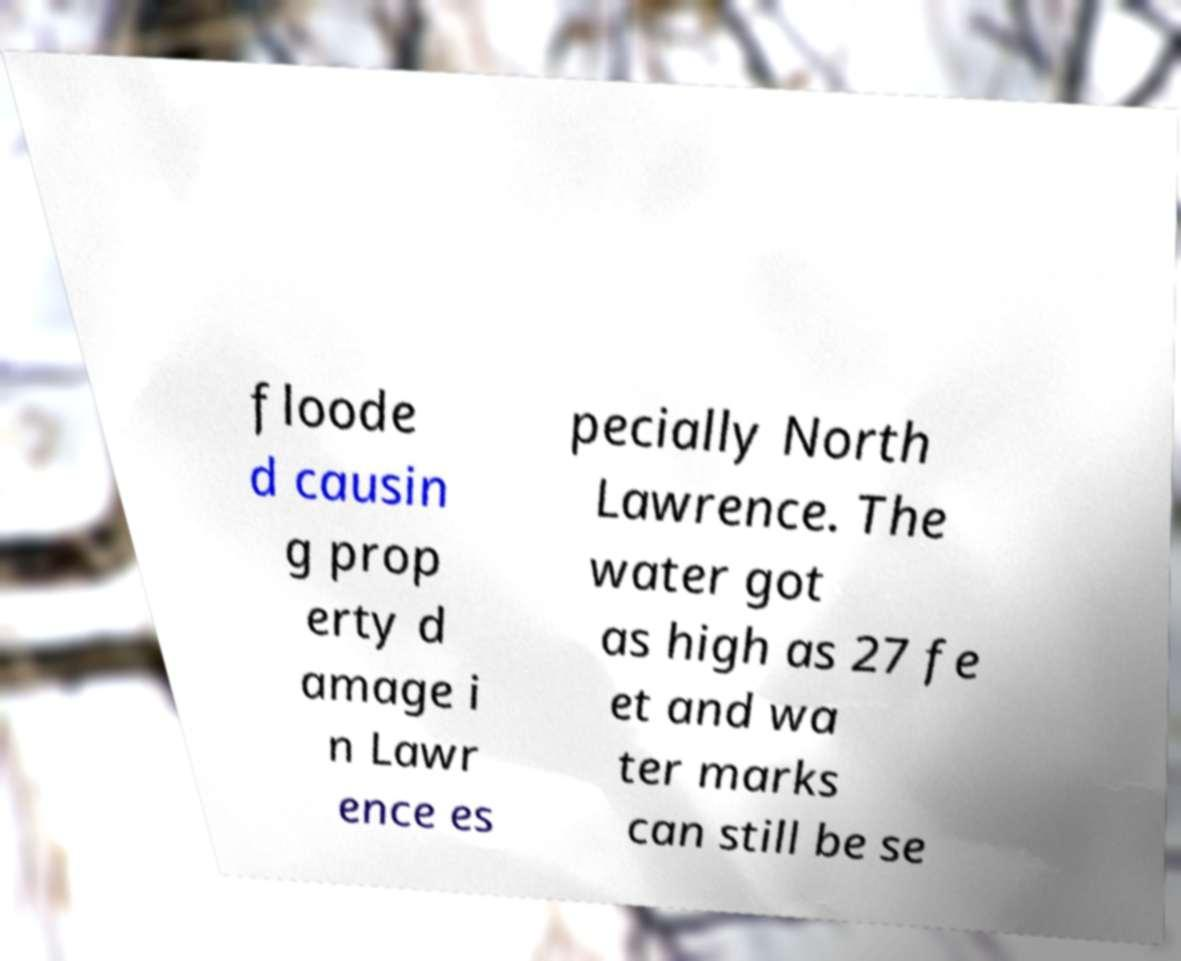Please read and relay the text visible in this image. What does it say? floode d causin g prop erty d amage i n Lawr ence es pecially North Lawrence. The water got as high as 27 fe et and wa ter marks can still be se 